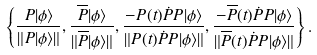<formula> <loc_0><loc_0><loc_500><loc_500>\left \{ \frac { P | \phi \rangle } { \| P | \phi \rangle \| } , \frac { \overline { P } | \phi \rangle } { \| \overline { P } | \phi \rangle \| } , \frac { - P ( t ) \dot { P } P | \phi \rangle } { \| P ( t ) \dot { P } P | \phi \rangle \| } , \frac { - \overline { P } ( t ) \dot { P } P | \phi \rangle } { \| \overline { P } ( t ) \dot { P } P | \phi \rangle \| } \right \} .</formula> 